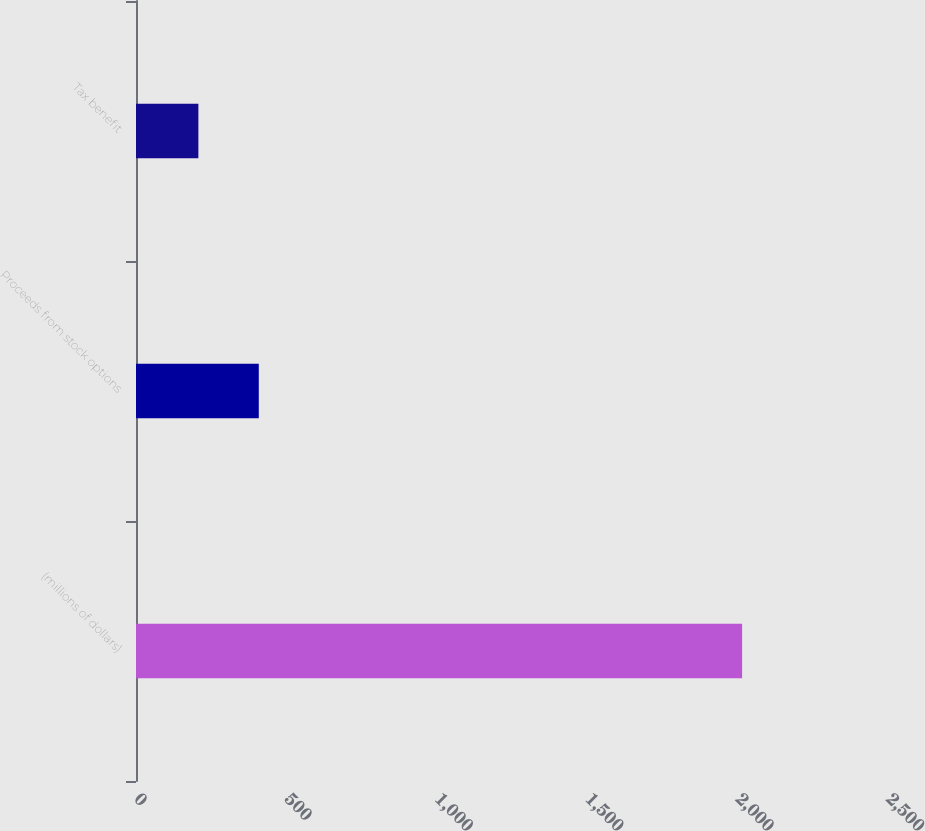Convert chart. <chart><loc_0><loc_0><loc_500><loc_500><bar_chart><fcel>(millions of dollars)<fcel>Proceeds from stock options<fcel>Tax benefit<nl><fcel>2015<fcel>408.2<fcel>207.35<nl></chart> 